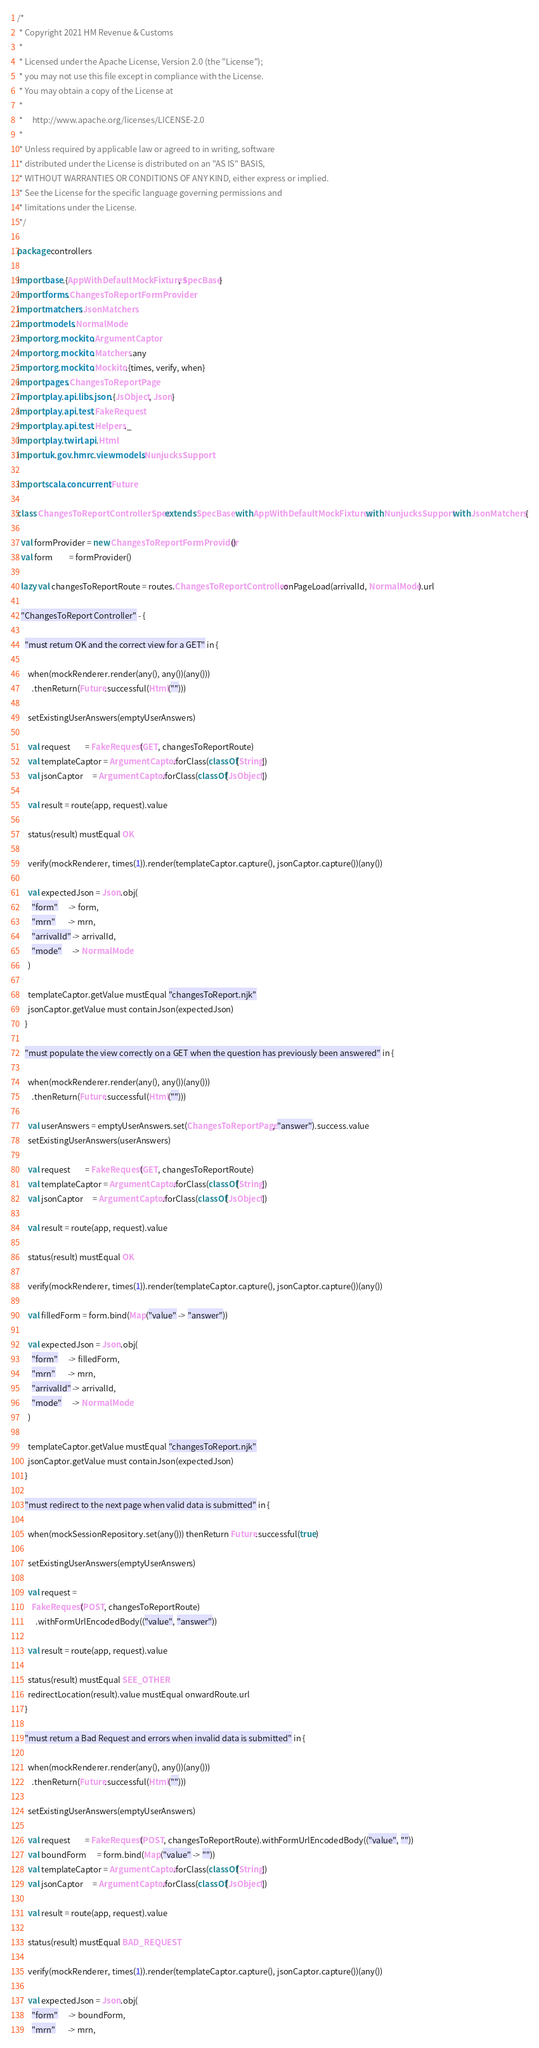Convert code to text. <code><loc_0><loc_0><loc_500><loc_500><_Scala_>/*
 * Copyright 2021 HM Revenue & Customs
 *
 * Licensed under the Apache License, Version 2.0 (the "License");
 * you may not use this file except in compliance with the License.
 * You may obtain a copy of the License at
 *
 *     http://www.apache.org/licenses/LICENSE-2.0
 *
 * Unless required by applicable law or agreed to in writing, software
 * distributed under the License is distributed on an "AS IS" BASIS,
 * WITHOUT WARRANTIES OR CONDITIONS OF ANY KIND, either express or implied.
 * See the License for the specific language governing permissions and
 * limitations under the License.
 */

package controllers

import base.{AppWithDefaultMockFixtures, SpecBase}
import forms.ChangesToReportFormProvider
import matchers.JsonMatchers
import models.NormalMode
import org.mockito.ArgumentCaptor
import org.mockito.Matchers.any
import org.mockito.Mockito.{times, verify, when}
import pages.ChangesToReportPage
import play.api.libs.json.{JsObject, Json}
import play.api.test.FakeRequest
import play.api.test.Helpers._
import play.twirl.api.Html
import uk.gov.hmrc.viewmodels.NunjucksSupport

import scala.concurrent.Future

class ChangesToReportControllerSpec extends SpecBase with AppWithDefaultMockFixtures with NunjucksSupport with JsonMatchers {

  val formProvider = new ChangesToReportFormProvider()
  val form         = formProvider()

  lazy val changesToReportRoute = routes.ChangesToReportController.onPageLoad(arrivalId, NormalMode).url

  "ChangesToReport Controller" - {

    "must return OK and the correct view for a GET" in {

      when(mockRenderer.render(any(), any())(any()))
        .thenReturn(Future.successful(Html("")))

      setExistingUserAnswers(emptyUserAnswers)

      val request        = FakeRequest(GET, changesToReportRoute)
      val templateCaptor = ArgumentCaptor.forClass(classOf[String])
      val jsonCaptor     = ArgumentCaptor.forClass(classOf[JsObject])

      val result = route(app, request).value

      status(result) mustEqual OK

      verify(mockRenderer, times(1)).render(templateCaptor.capture(), jsonCaptor.capture())(any())

      val expectedJson = Json.obj(
        "form"      -> form,
        "mrn"       -> mrn,
        "arrivalId" -> arrivalId,
        "mode"      -> NormalMode
      )

      templateCaptor.getValue mustEqual "changesToReport.njk"
      jsonCaptor.getValue must containJson(expectedJson)
    }

    "must populate the view correctly on a GET when the question has previously been answered" in {

      when(mockRenderer.render(any(), any())(any()))
        .thenReturn(Future.successful(Html("")))

      val userAnswers = emptyUserAnswers.set(ChangesToReportPage, "answer").success.value
      setExistingUserAnswers(userAnswers)

      val request        = FakeRequest(GET, changesToReportRoute)
      val templateCaptor = ArgumentCaptor.forClass(classOf[String])
      val jsonCaptor     = ArgumentCaptor.forClass(classOf[JsObject])

      val result = route(app, request).value

      status(result) mustEqual OK

      verify(mockRenderer, times(1)).render(templateCaptor.capture(), jsonCaptor.capture())(any())

      val filledForm = form.bind(Map("value" -> "answer"))

      val expectedJson = Json.obj(
        "form"      -> filledForm,
        "mrn"       -> mrn,
        "arrivalId" -> arrivalId,
        "mode"      -> NormalMode
      )

      templateCaptor.getValue mustEqual "changesToReport.njk"
      jsonCaptor.getValue must containJson(expectedJson)
    }

    "must redirect to the next page when valid data is submitted" in {

      when(mockSessionRepository.set(any())) thenReturn Future.successful(true)

      setExistingUserAnswers(emptyUserAnswers)

      val request =
        FakeRequest(POST, changesToReportRoute)
          .withFormUrlEncodedBody(("value", "answer"))

      val result = route(app, request).value

      status(result) mustEqual SEE_OTHER
      redirectLocation(result).value mustEqual onwardRoute.url
    }

    "must return a Bad Request and errors when invalid data is submitted" in {

      when(mockRenderer.render(any(), any())(any()))
        .thenReturn(Future.successful(Html("")))

      setExistingUserAnswers(emptyUserAnswers)

      val request        = FakeRequest(POST, changesToReportRoute).withFormUrlEncodedBody(("value", ""))
      val boundForm      = form.bind(Map("value" -> ""))
      val templateCaptor = ArgumentCaptor.forClass(classOf[String])
      val jsonCaptor     = ArgumentCaptor.forClass(classOf[JsObject])

      val result = route(app, request).value

      status(result) mustEqual BAD_REQUEST

      verify(mockRenderer, times(1)).render(templateCaptor.capture(), jsonCaptor.capture())(any())

      val expectedJson = Json.obj(
        "form"      -> boundForm,
        "mrn"       -> mrn,</code> 